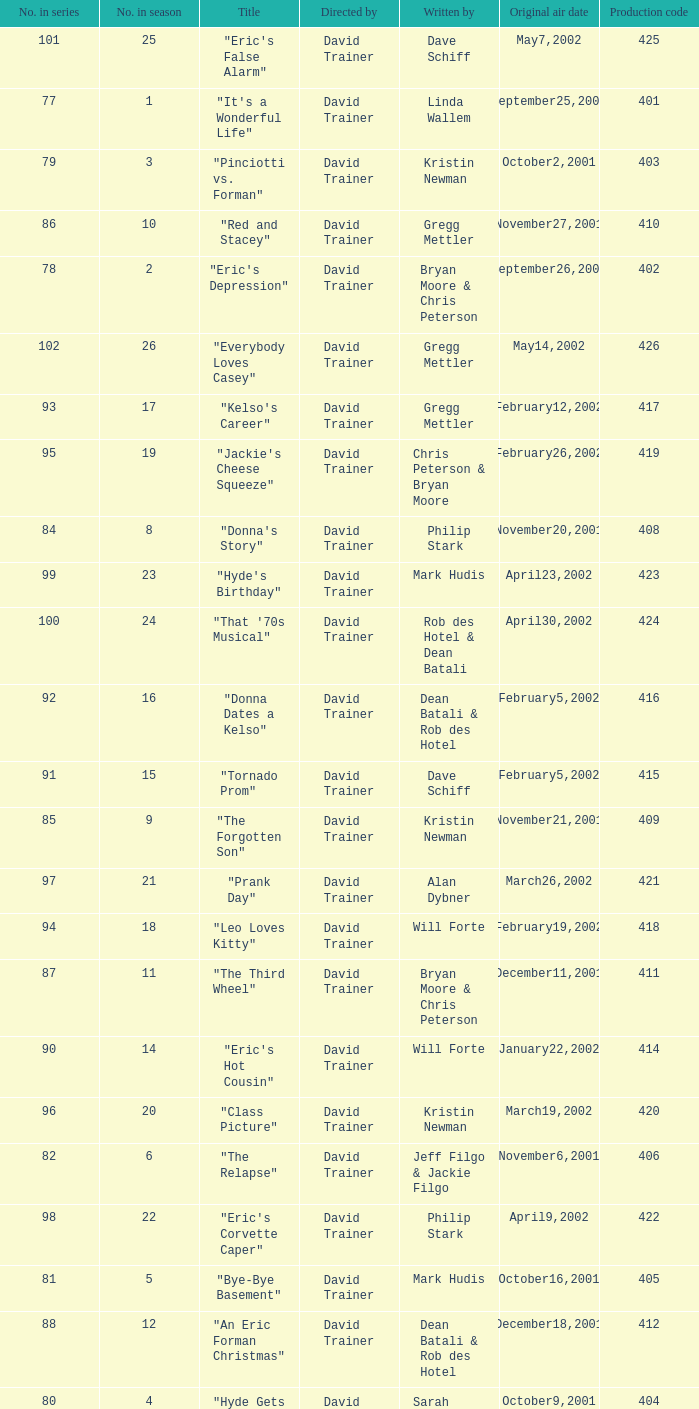How many production codes had a total number in the season of 8? 1.0. 